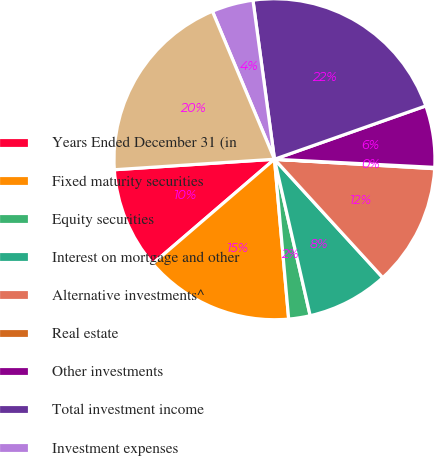<chart> <loc_0><loc_0><loc_500><loc_500><pie_chart><fcel>Years Ended December 31 (in<fcel>Fixed maturity securities<fcel>Equity securities<fcel>Interest on mortgage and other<fcel>Alternative investments^<fcel>Real estate<fcel>Other investments<fcel>Total investment income<fcel>Investment expenses<fcel>Net investment income<nl><fcel>10.25%<fcel>15.12%<fcel>2.16%<fcel>8.22%<fcel>12.27%<fcel>0.13%<fcel>6.2%<fcel>21.75%<fcel>4.18%<fcel>19.72%<nl></chart> 